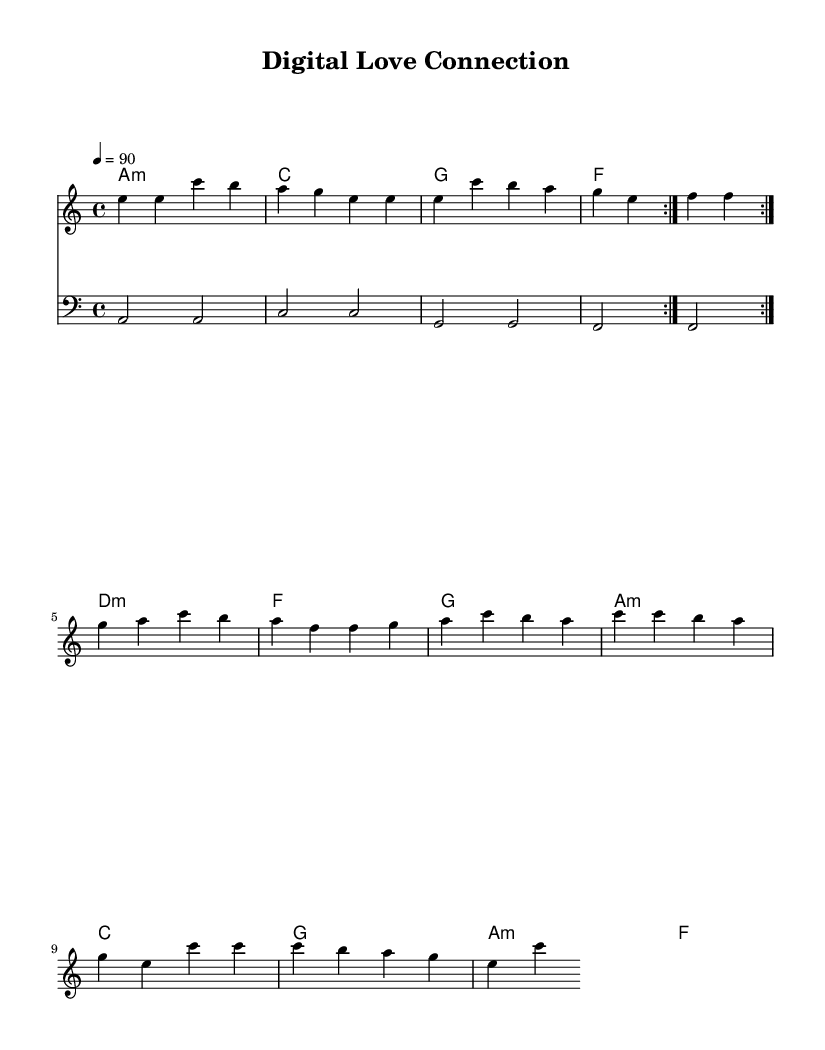What is the key signature of this music? The key signature is A minor, which has no sharps or flats. This can be identified at the beginning of the music, where the key signature is indicated.
Answer: A minor What is the time signature of this piece? The time signature is 4/4, which means there are four beats in each measure and the quarter note gets one beat. This is shown at the start of the sheet music.
Answer: 4/4 What is the tempo marking for this piece? The tempo marking is 90, indicating that the piece should be played at a speed of 90 beats per minute. This is displayed above the music at the start.
Answer: 90 How many times is the melody section meant to be repeated? The melody section is meant to be repeated twice, as indicated by the "volta" notation at the beginning of the repeat section.
Answer: 2 Which chord follows the D minor chord in the progression? The chord that follows the D minor chord is F. This can be determined by analyzing the chord progression provided in the chord names section.
Answer: F What is the lowest note in the bass line? The lowest note in the bass line is A, which is the first note played in the bass line throughout the piece. This can be found by inspecting the bass staff notation.
Answer: A Which musical genre does this sheet music specifically represent? This sheet music represents the genre of Contemporary R&B, as indicated by the themes and characteristics present in the melody and lyrics represented within the context of the music.
Answer: Contemporary R&B 